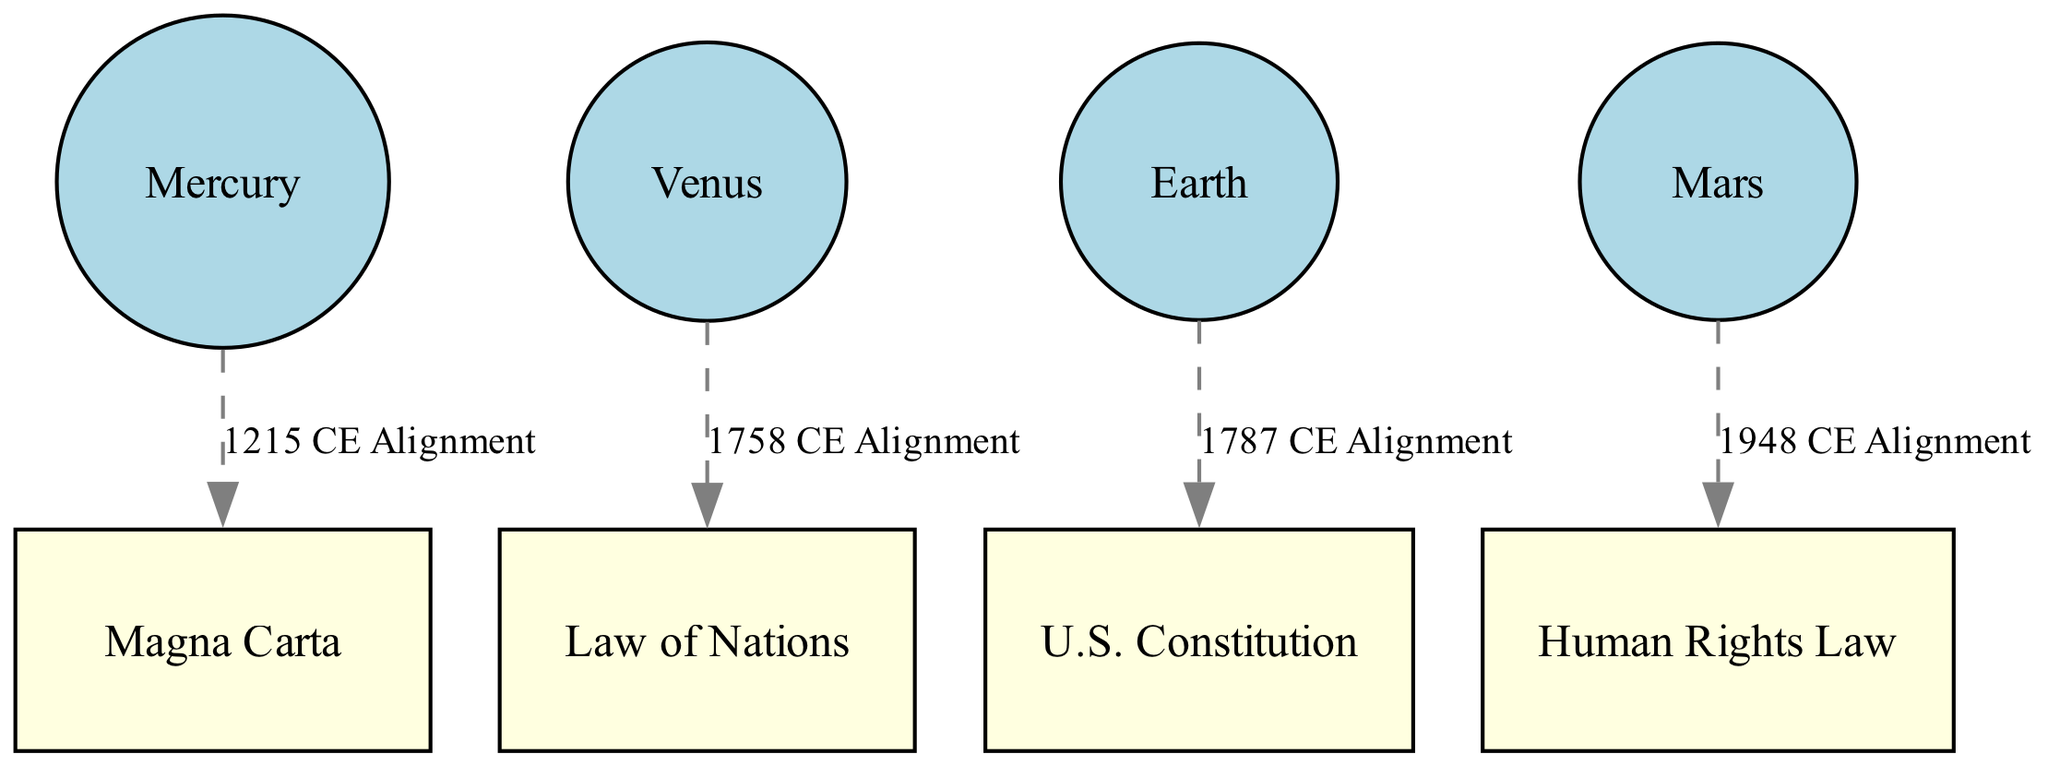What are the four planets depicted in the diagram? The diagram contains nodes representing four planets: Mercury, Venus, Earth, and Mars. This can be observed by counting the nodes specifically labeled as planets.
Answer: Mercury, Venus, Earth, Mars How many historical legal milestones are shown in the diagram? There are four historical legal milestones displayed, which can be identified by counting the nodes labeled as such, specifically: Law of Nations, Magna Carta, U.S. Constitution, and Human Rights Law.
Answer: Four What planet aligns with the U.S. Constitution? The diagram shows that Earth aligns with the U.S. Constitution, as indicated by the edge connecting these two nodes with the label "1787 CE Alignment."
Answer: Earth What year is associated with the alignment of Mars? The alignment of Mars with a historical legal milestone is noted as 1948 CE, based on the edge connecting Mars to Human Rights Law, which is labeled accordingly.
Answer: 1948 CE Which historical milestone is connected to Mercury? Mercury is connected to the Magna Carta, as shown by the edge labelled "1215 CE Alignment" linking these two nodes together.
Answer: Magna Carta Which planet is associated with the Law of Nations? Venus is associated with the Law of Nations, as indicated by the connection shown via the edge labeled "1758 CE Alignment."
Answer: Venus How many edges are in this diagram? The diagram contains four edges, which can be verified by counting the lines connecting the planet nodes to the legal milestone nodes.
Answer: Four Which legal precedent aligns with Venus? Venus aligns with the Law of Nations, as shown by the direct edge connecting the two nodes with the alignment label.
Answer: Law of Nations What type of edges are used to connect the nodes? The edges connecting the nodes are labeled as dashed, with the style described in the graph settings of the diagram.
Answer: Dashed What is the alignment date for Earth? The alignment date for Earth is 1787 CE, which can be seen on the edge connecting Earth to the U.S. Constitution.
Answer: 1787 CE 